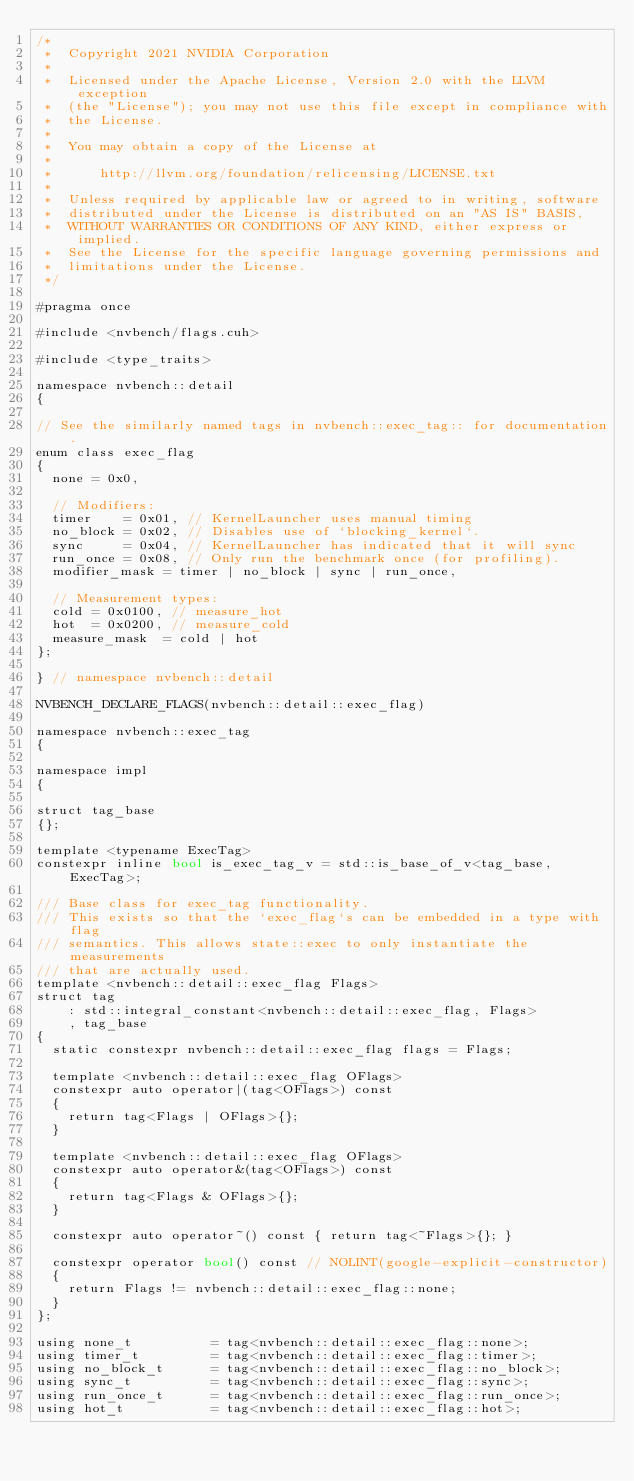Convert code to text. <code><loc_0><loc_0><loc_500><loc_500><_Cuda_>/*
 *  Copyright 2021 NVIDIA Corporation
 *
 *  Licensed under the Apache License, Version 2.0 with the LLVM exception
 *  (the "License"); you may not use this file except in compliance with
 *  the License.
 *
 *  You may obtain a copy of the License at
 *
 *      http://llvm.org/foundation/relicensing/LICENSE.txt
 *
 *  Unless required by applicable law or agreed to in writing, software
 *  distributed under the License is distributed on an "AS IS" BASIS,
 *  WITHOUT WARRANTIES OR CONDITIONS OF ANY KIND, either express or implied.
 *  See the License for the specific language governing permissions and
 *  limitations under the License.
 */

#pragma once

#include <nvbench/flags.cuh>

#include <type_traits>

namespace nvbench::detail
{

// See the similarly named tags in nvbench::exec_tag:: for documentation.
enum class exec_flag
{
  none = 0x0,

  // Modifiers:
  timer    = 0x01, // KernelLauncher uses manual timing
  no_block = 0x02, // Disables use of `blocking_kernel`.
  sync     = 0x04, // KernelLauncher has indicated that it will sync
  run_once = 0x08, // Only run the benchmark once (for profiling).
  modifier_mask = timer | no_block | sync | run_once,

  // Measurement types:
  cold = 0x0100, // measure_hot
  hot  = 0x0200, // measure_cold
  measure_mask  = cold | hot
};

} // namespace nvbench::detail

NVBENCH_DECLARE_FLAGS(nvbench::detail::exec_flag)

namespace nvbench::exec_tag
{

namespace impl
{

struct tag_base
{};

template <typename ExecTag>
constexpr inline bool is_exec_tag_v = std::is_base_of_v<tag_base, ExecTag>;

/// Base class for exec_tag functionality.
/// This exists so that the `exec_flag`s can be embedded in a type with flag
/// semantics. This allows state::exec to only instantiate the measurements
/// that are actually used.
template <nvbench::detail::exec_flag Flags>
struct tag
    : std::integral_constant<nvbench::detail::exec_flag, Flags>
    , tag_base
{
  static constexpr nvbench::detail::exec_flag flags = Flags;

  template <nvbench::detail::exec_flag OFlags>
  constexpr auto operator|(tag<OFlags>) const
  {
    return tag<Flags | OFlags>{};
  }

  template <nvbench::detail::exec_flag OFlags>
  constexpr auto operator&(tag<OFlags>) const
  {
    return tag<Flags & OFlags>{};
  }

  constexpr auto operator~() const { return tag<~Flags>{}; }

  constexpr operator bool() const // NOLINT(google-explicit-constructor)
  {
    return Flags != nvbench::detail::exec_flag::none;
  }
};

using none_t          = tag<nvbench::detail::exec_flag::none>;
using timer_t         = tag<nvbench::detail::exec_flag::timer>;
using no_block_t      = tag<nvbench::detail::exec_flag::no_block>;
using sync_t          = tag<nvbench::detail::exec_flag::sync>;
using run_once_t      = tag<nvbench::detail::exec_flag::run_once>;
using hot_t           = tag<nvbench::detail::exec_flag::hot>;</code> 